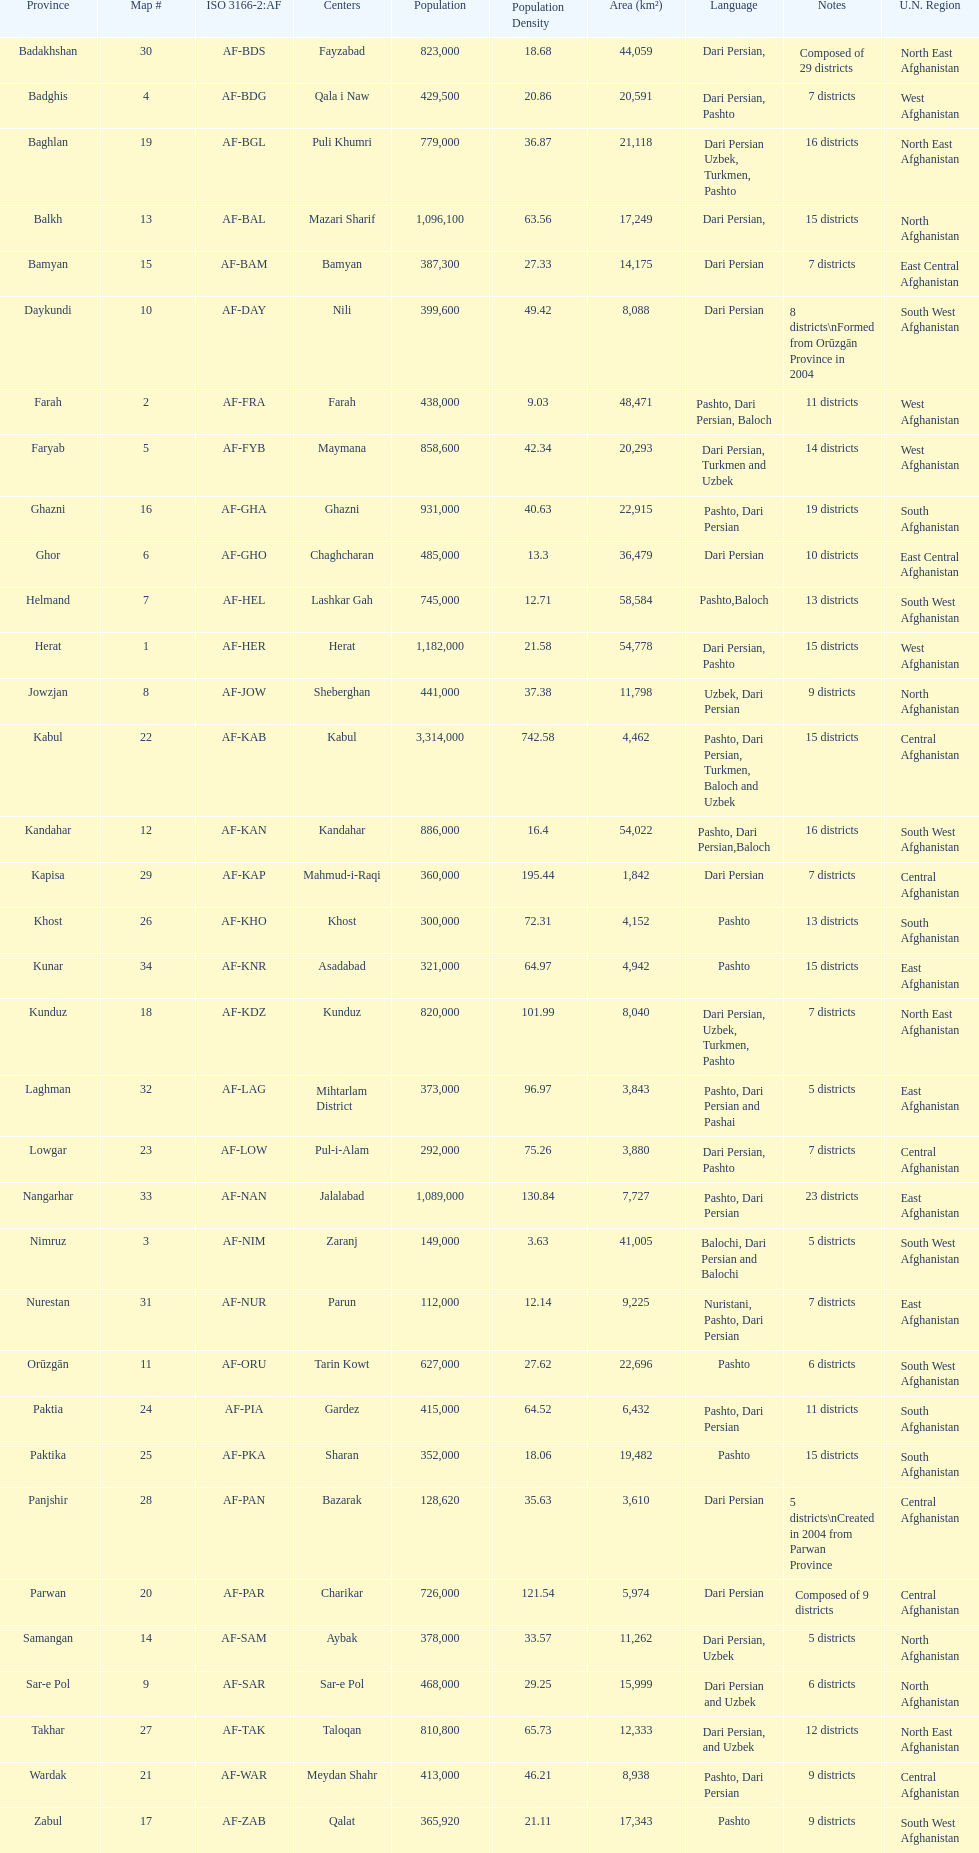Does ghor or farah have more districts? Farah. 